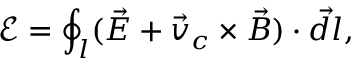Convert formula to latex. <formula><loc_0><loc_0><loc_500><loc_500>\mathcal { E } = \oint _ { l } ( \vec { E } + \vec { v } _ { c } \times \vec { B } ) \cdot \vec { d l } ,</formula> 